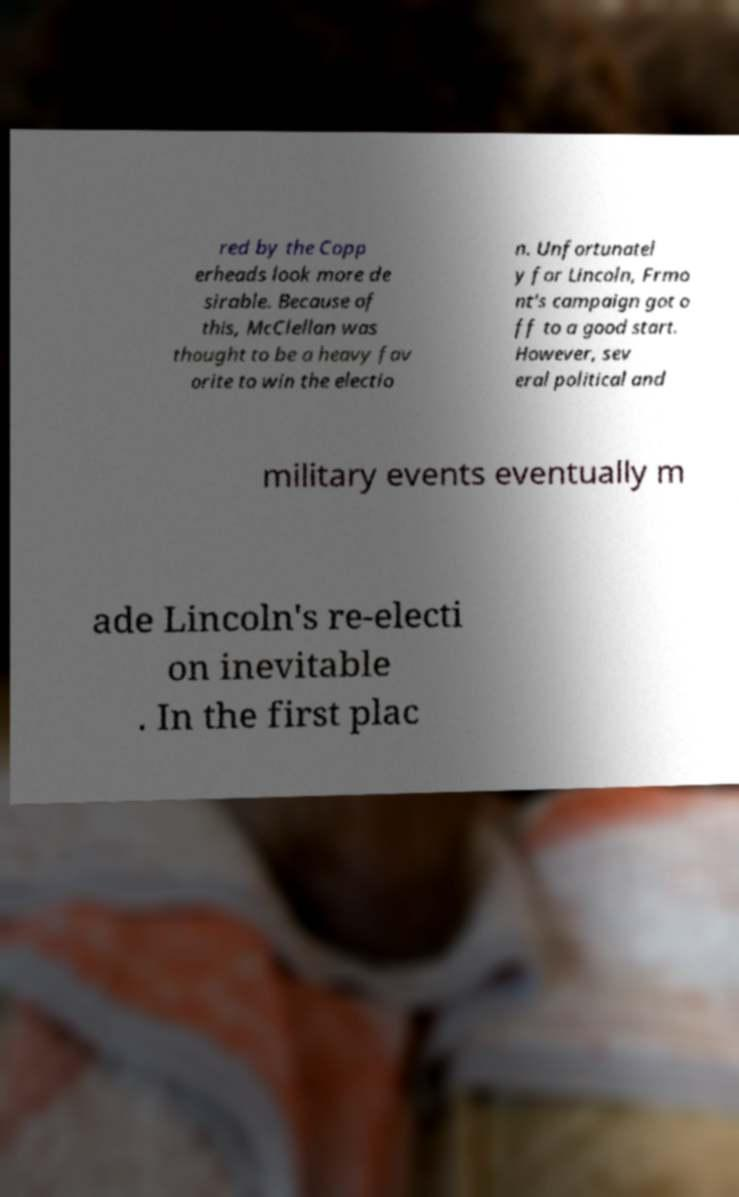For documentation purposes, I need the text within this image transcribed. Could you provide that? red by the Copp erheads look more de sirable. Because of this, McClellan was thought to be a heavy fav orite to win the electio n. Unfortunatel y for Lincoln, Frmo nt's campaign got o ff to a good start. However, sev eral political and military events eventually m ade Lincoln's re-electi on inevitable . In the first plac 